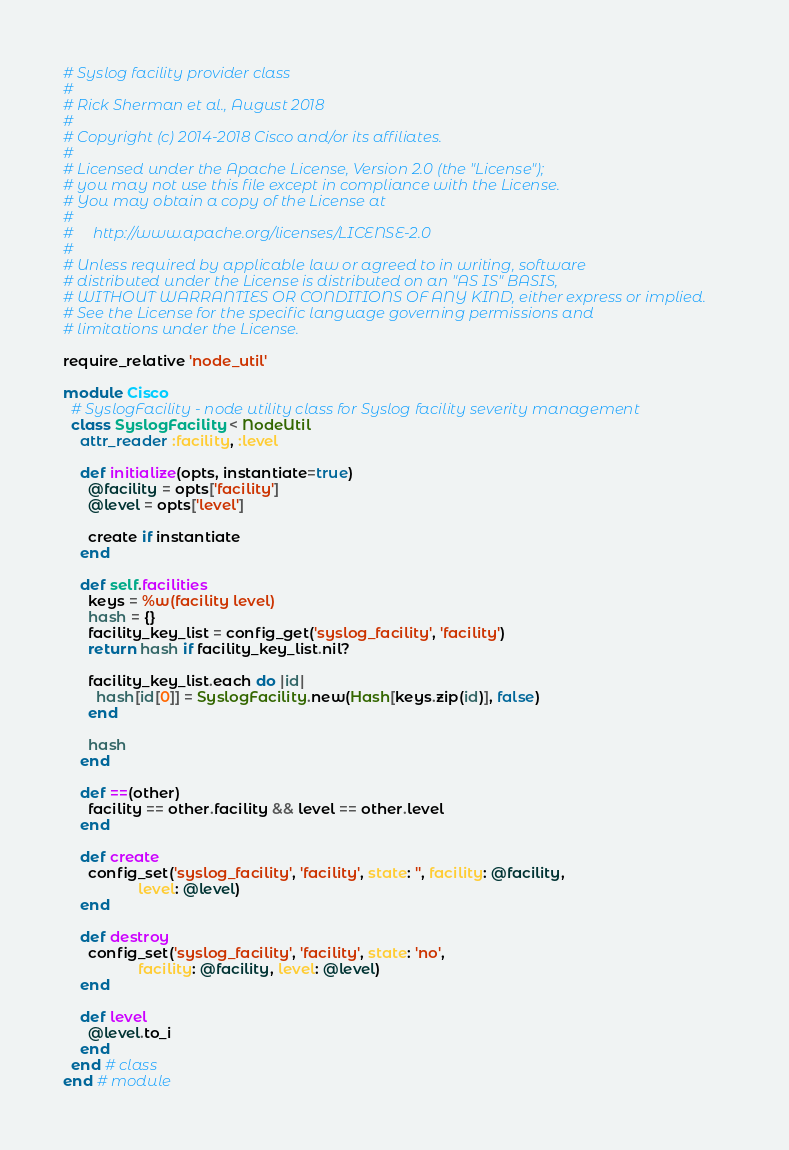Convert code to text. <code><loc_0><loc_0><loc_500><loc_500><_Ruby_># Syslog facility provider class
#
# Rick Sherman et al., August 2018
#
# Copyright (c) 2014-2018 Cisco and/or its affiliates.
#
# Licensed under the Apache License, Version 2.0 (the "License");
# you may not use this file except in compliance with the License.
# You may obtain a copy of the License at
#
#     http://www.apache.org/licenses/LICENSE-2.0
#
# Unless required by applicable law or agreed to in writing, software
# distributed under the License is distributed on an "AS IS" BASIS,
# WITHOUT WARRANTIES OR CONDITIONS OF ANY KIND, either express or implied.
# See the License for the specific language governing permissions and
# limitations under the License.

require_relative 'node_util'

module Cisco
  # SyslogFacility - node utility class for Syslog facility severity management
  class SyslogFacility < NodeUtil
    attr_reader :facility, :level

    def initialize(opts, instantiate=true)
      @facility = opts['facility']
      @level = opts['level']

      create if instantiate
    end

    def self.facilities
      keys = %w(facility level)
      hash = {}
      facility_key_list = config_get('syslog_facility', 'facility')
      return hash if facility_key_list.nil?

      facility_key_list.each do |id|
        hash[id[0]] = SyslogFacility.new(Hash[keys.zip(id)], false)
      end

      hash
    end

    def ==(other)
      facility == other.facility && level == other.level
    end

    def create
      config_set('syslog_facility', 'facility', state: '', facility: @facility,
                  level: @level)
    end

    def destroy
      config_set('syslog_facility', 'facility', state: 'no',
                  facility: @facility, level: @level)
    end

    def level
      @level.to_i
    end
  end # class
end # module
</code> 